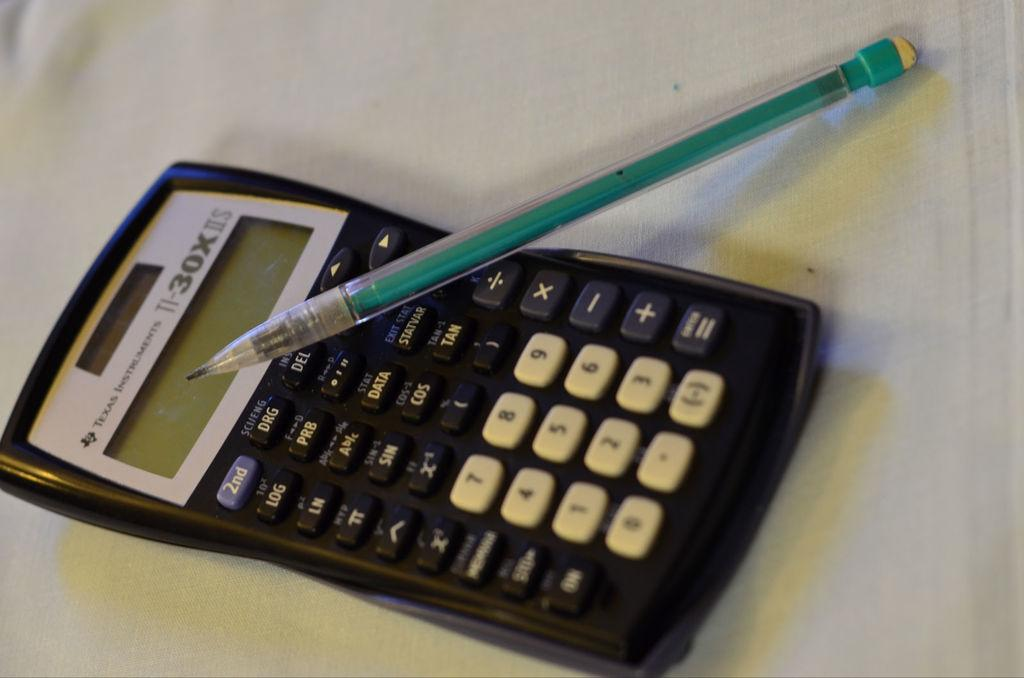<image>
Present a compact description of the photo's key features. The calculator shown is from Texas Instruments with the number 30x at top. 